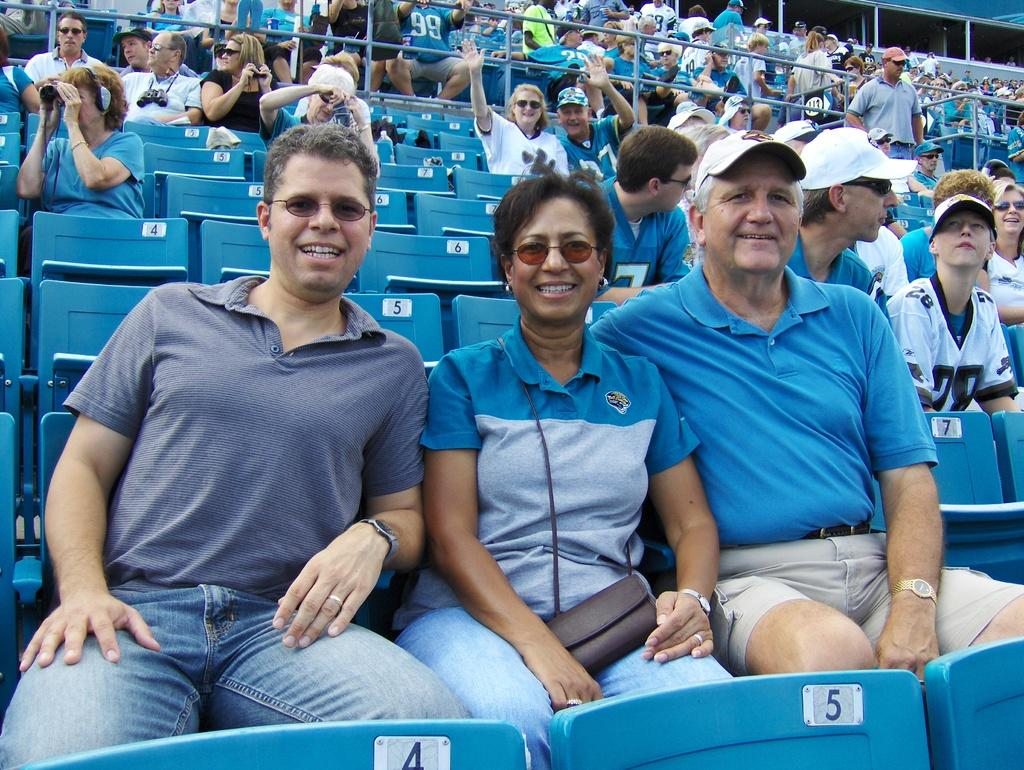How many people are in the image? There are persons in the image, but the exact number is not specified. What are the persons wearing? The persons are wearing clothes. What are the persons doing in the image? The persons are sitting on chairs. What can be seen at the top of the image? There are safety grills at the top of the image. What type of destruction can be seen happening to the chairs in the image? There is no destruction happening to the chairs in the image; the persons are sitting on them. How many eggs are visible on the chairs in the image? There are no eggs present in the image. 